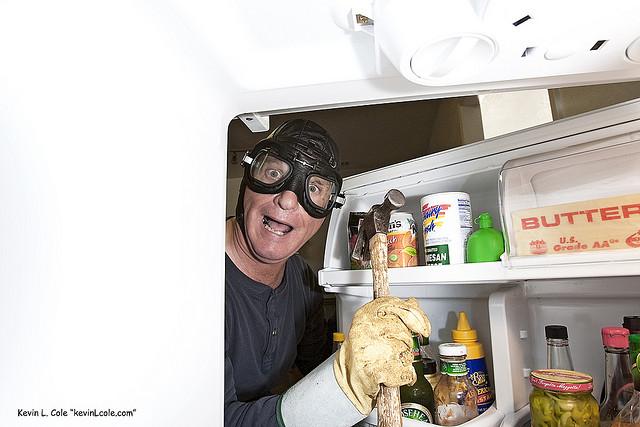What is in the right top shelf?
Short answer required. Butter. What is on his face?
Keep it brief. Goggles. Is this a well-organized refrigerator?
Short answer required. No. Is he wearing gloves?
Keep it brief. Yes. Is the butter drawer open or closed?
Be succinct. Closed. 